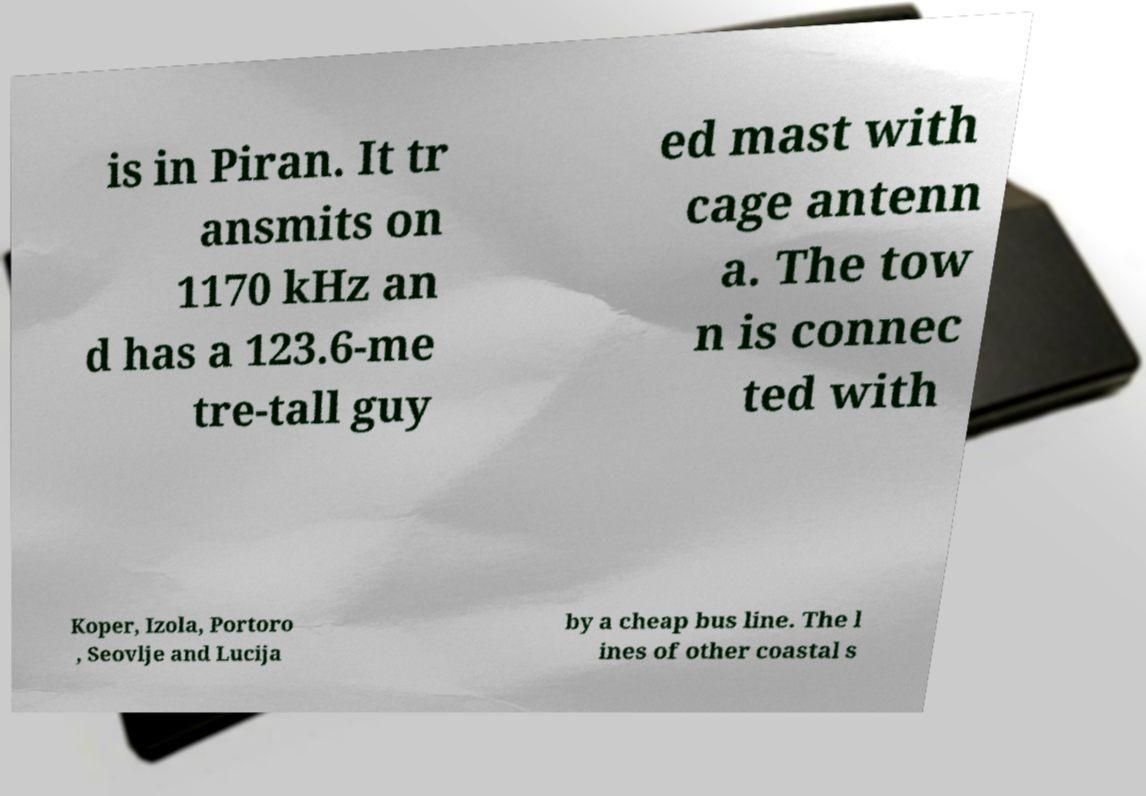I need the written content from this picture converted into text. Can you do that? is in Piran. It tr ansmits on 1170 kHz an d has a 123.6-me tre-tall guy ed mast with cage antenn a. The tow n is connec ted with Koper, Izola, Portoro , Seovlje and Lucija by a cheap bus line. The l ines of other coastal s 